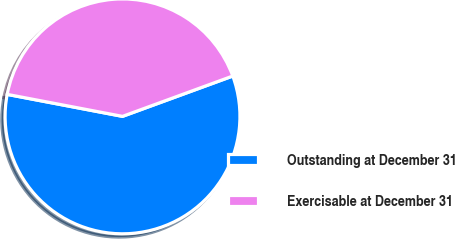<chart> <loc_0><loc_0><loc_500><loc_500><pie_chart><fcel>Outstanding at December 31<fcel>Exercisable at December 31<nl><fcel>58.58%<fcel>41.42%<nl></chart> 